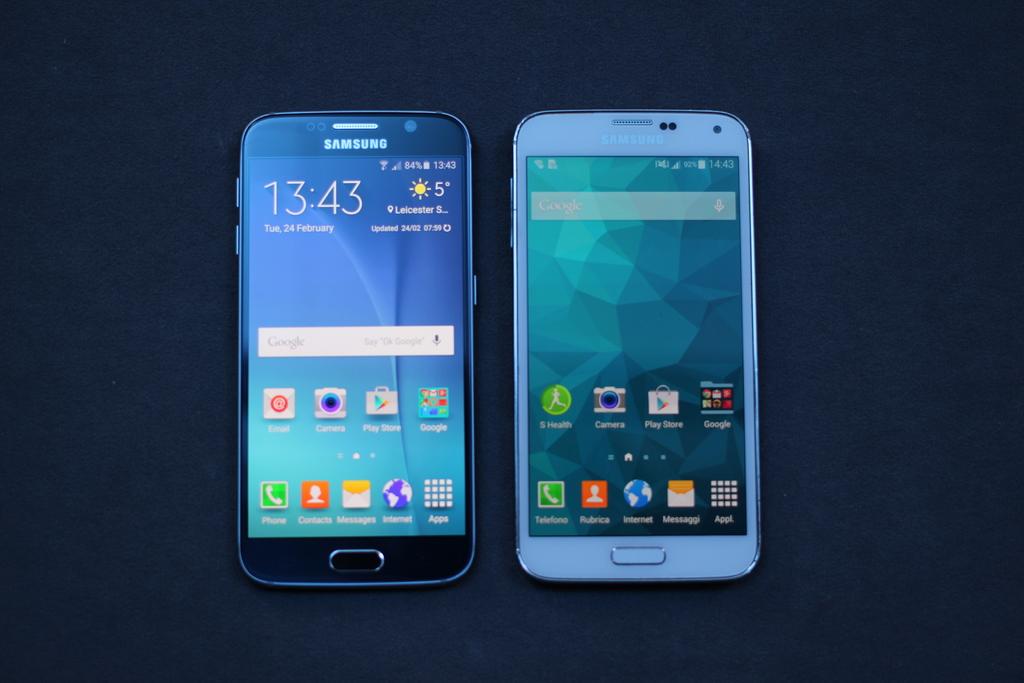What temperature does the phone display?
Ensure brevity in your answer.  5. What brand of phone is shown on the left?
Give a very brief answer. Samsung. 